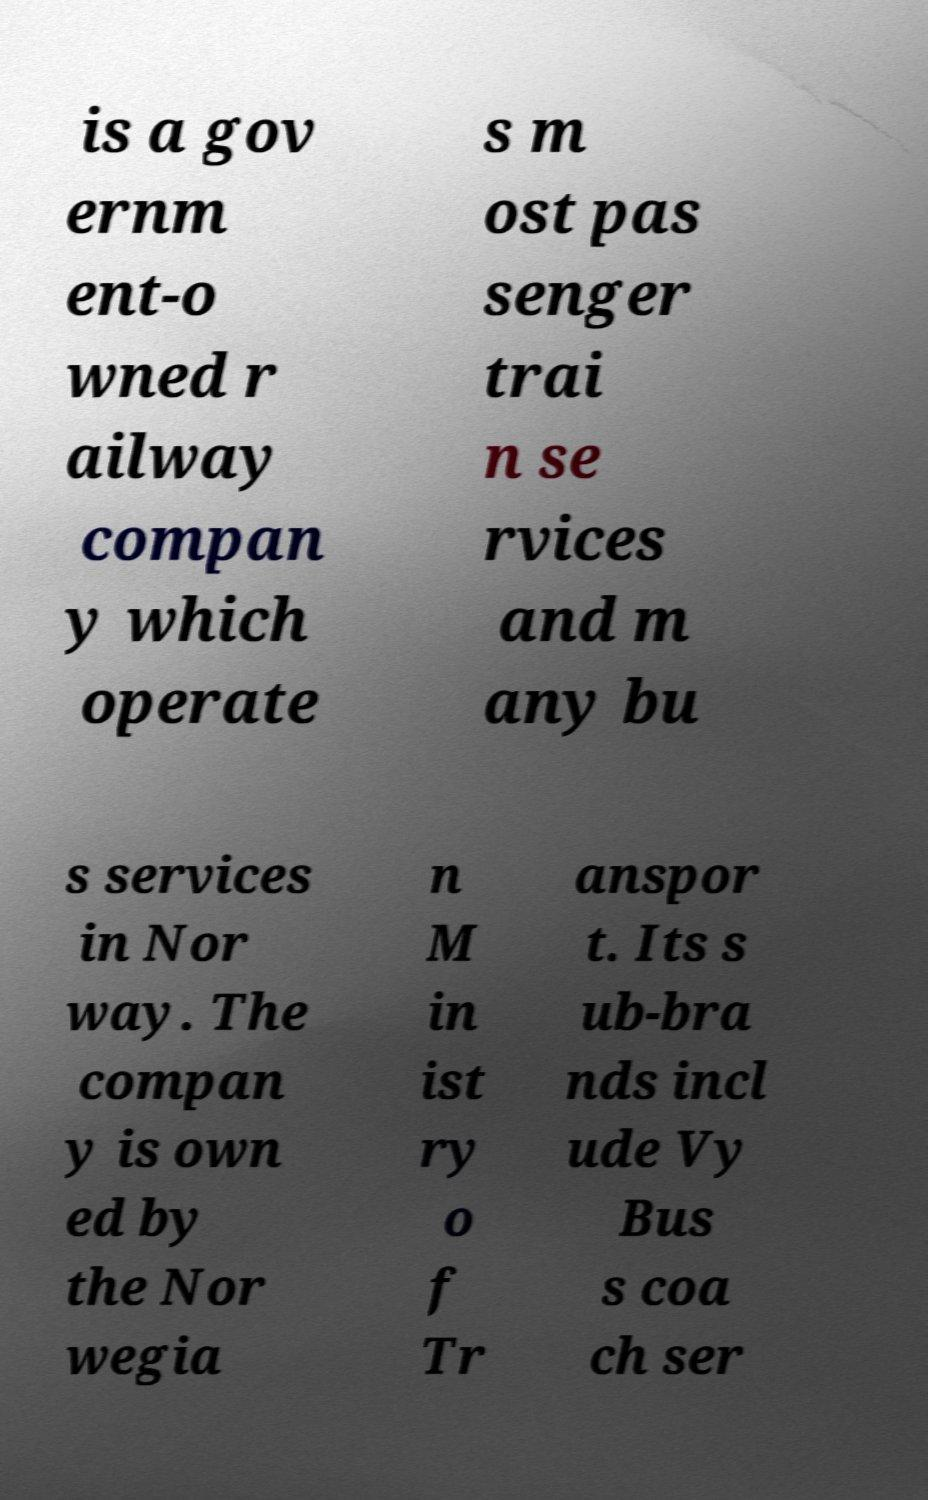What messages or text are displayed in this image? I need them in a readable, typed format. is a gov ernm ent-o wned r ailway compan y which operate s m ost pas senger trai n se rvices and m any bu s services in Nor way. The compan y is own ed by the Nor wegia n M in ist ry o f Tr anspor t. Its s ub-bra nds incl ude Vy Bus s coa ch ser 